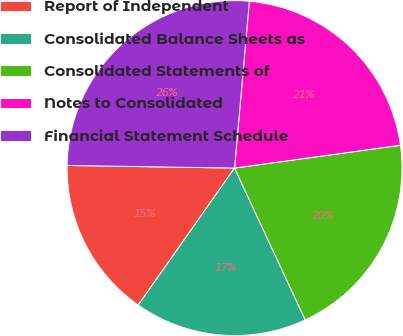Convert chart to OTSL. <chart><loc_0><loc_0><loc_500><loc_500><pie_chart><fcel>Report of Independent<fcel>Consolidated Balance Sheets as<fcel>Consolidated Statements of<fcel>Notes to Consolidated<fcel>Financial Statement Schedule<nl><fcel>15.5%<fcel>16.69%<fcel>20.24%<fcel>21.42%<fcel>26.16%<nl></chart> 